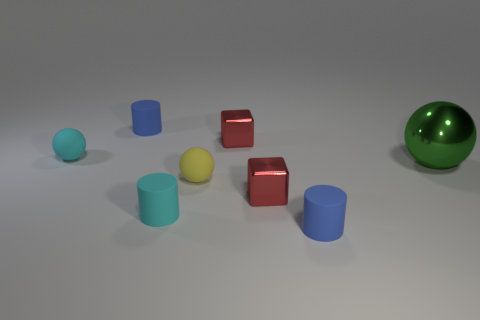Add 1 yellow objects. How many objects exist? 9 Subtract all blocks. How many objects are left? 6 Add 2 green shiny objects. How many green shiny objects exist? 3 Subtract 2 blue cylinders. How many objects are left? 6 Subtract all small shiny objects. Subtract all cyan rubber things. How many objects are left? 4 Add 2 yellow balls. How many yellow balls are left? 3 